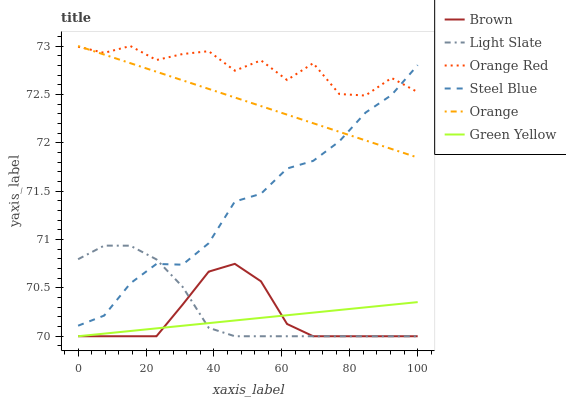Does Light Slate have the minimum area under the curve?
Answer yes or no. No. Does Light Slate have the maximum area under the curve?
Answer yes or no. No. Is Light Slate the smoothest?
Answer yes or no. No. Is Light Slate the roughest?
Answer yes or no. No. Does Steel Blue have the lowest value?
Answer yes or no. No. Does Light Slate have the highest value?
Answer yes or no. No. Is Light Slate less than Orange?
Answer yes or no. Yes. Is Orange Red greater than Green Yellow?
Answer yes or no. Yes. Does Light Slate intersect Orange?
Answer yes or no. No. 